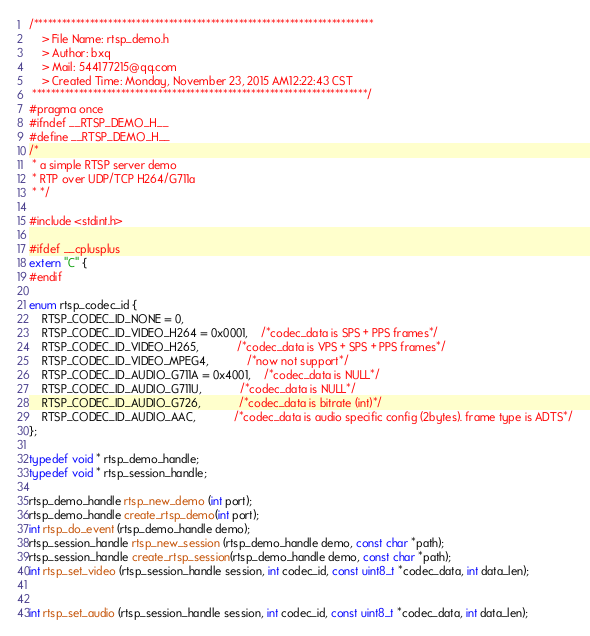<code> <loc_0><loc_0><loc_500><loc_500><_C_>/*************************************************************************
	> File Name: rtsp_demo.h
	> Author: bxq
	> Mail: 544177215@qq.com 
	> Created Time: Monday, November 23, 2015 AM12:22:43 CST
 ************************************************************************/
#pragma once
#ifndef __RTSP_DEMO_H__
#define __RTSP_DEMO_H__
/*
 * a simple RTSP server demo
 * RTP over UDP/TCP H264/G711a 
 * */

#include <stdint.h>

#ifdef __cplusplus
extern "C" {
#endif

enum rtsp_codec_id {
	RTSP_CODEC_ID_NONE = 0,
	RTSP_CODEC_ID_VIDEO_H264 = 0x0001,	/*codec_data is SPS + PPS frames*/
	RTSP_CODEC_ID_VIDEO_H265,			/*codec_data is VPS + SPS + PPS frames*/
	RTSP_CODEC_ID_VIDEO_MPEG4,			/*now not support*/
	RTSP_CODEC_ID_AUDIO_G711A = 0x4001,	/*codec_data is NULL*/
	RTSP_CODEC_ID_AUDIO_G711U,			/*codec_data is NULL*/
	RTSP_CODEC_ID_AUDIO_G726,			/*codec_data is bitrate (int)*/
	RTSP_CODEC_ID_AUDIO_AAC,			/*codec_data is audio specific config (2bytes). frame type is ADTS*/
};

typedef void * rtsp_demo_handle;
typedef void * rtsp_session_handle;

rtsp_demo_handle rtsp_new_demo (int port);
rtsp_demo_handle create_rtsp_demo(int port);
int rtsp_do_event (rtsp_demo_handle demo);
rtsp_session_handle rtsp_new_session (rtsp_demo_handle demo, const char *path);
rtsp_session_handle create_rtsp_session(rtsp_demo_handle demo, const char *path);
int rtsp_set_video (rtsp_session_handle session, int codec_id, const uint8_t *codec_data, int data_len);


int rtsp_set_audio (rtsp_session_handle session, int codec_id, const uint8_t *codec_data, int data_len);
</code> 